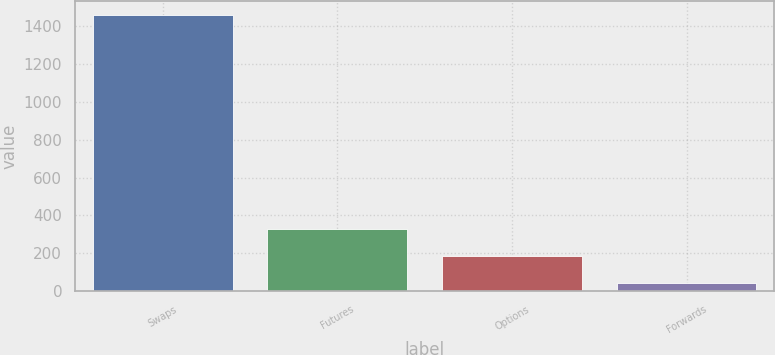Convert chart to OTSL. <chart><loc_0><loc_0><loc_500><loc_500><bar_chart><fcel>Swaps<fcel>Futures<fcel>Options<fcel>Forwards<nl><fcel>1460<fcel>328<fcel>186.5<fcel>45<nl></chart> 